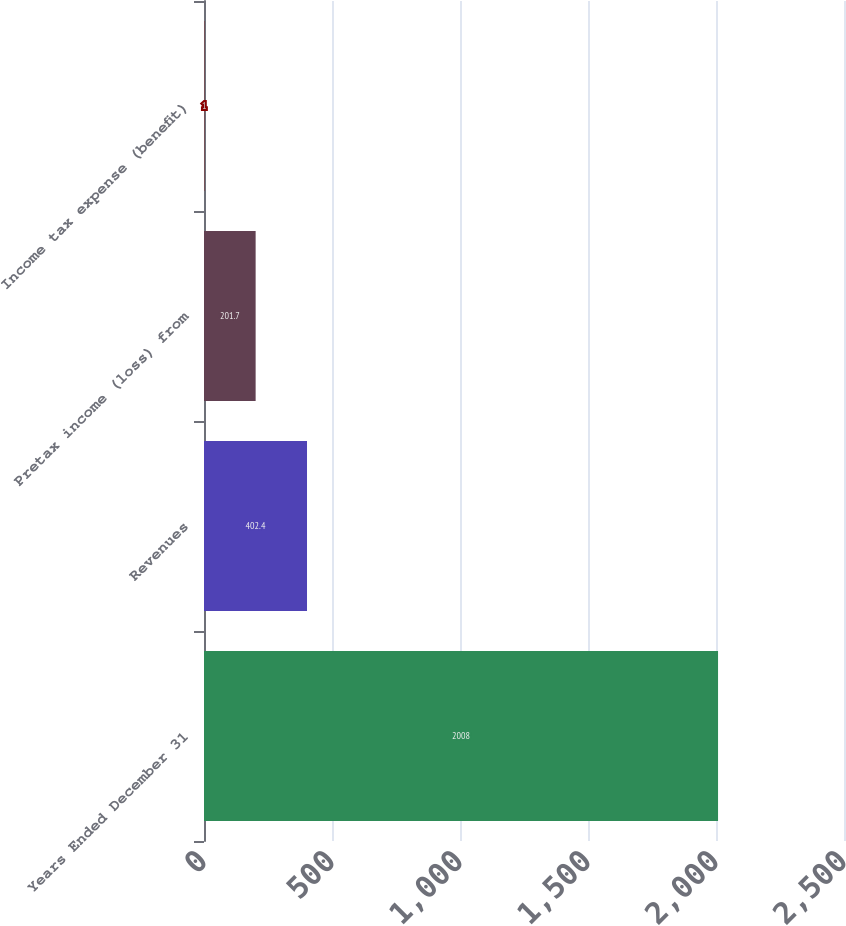<chart> <loc_0><loc_0><loc_500><loc_500><bar_chart><fcel>Years Ended December 31<fcel>Revenues<fcel>Pretax income (loss) from<fcel>Income tax expense (benefit)<nl><fcel>2008<fcel>402.4<fcel>201.7<fcel>1<nl></chart> 